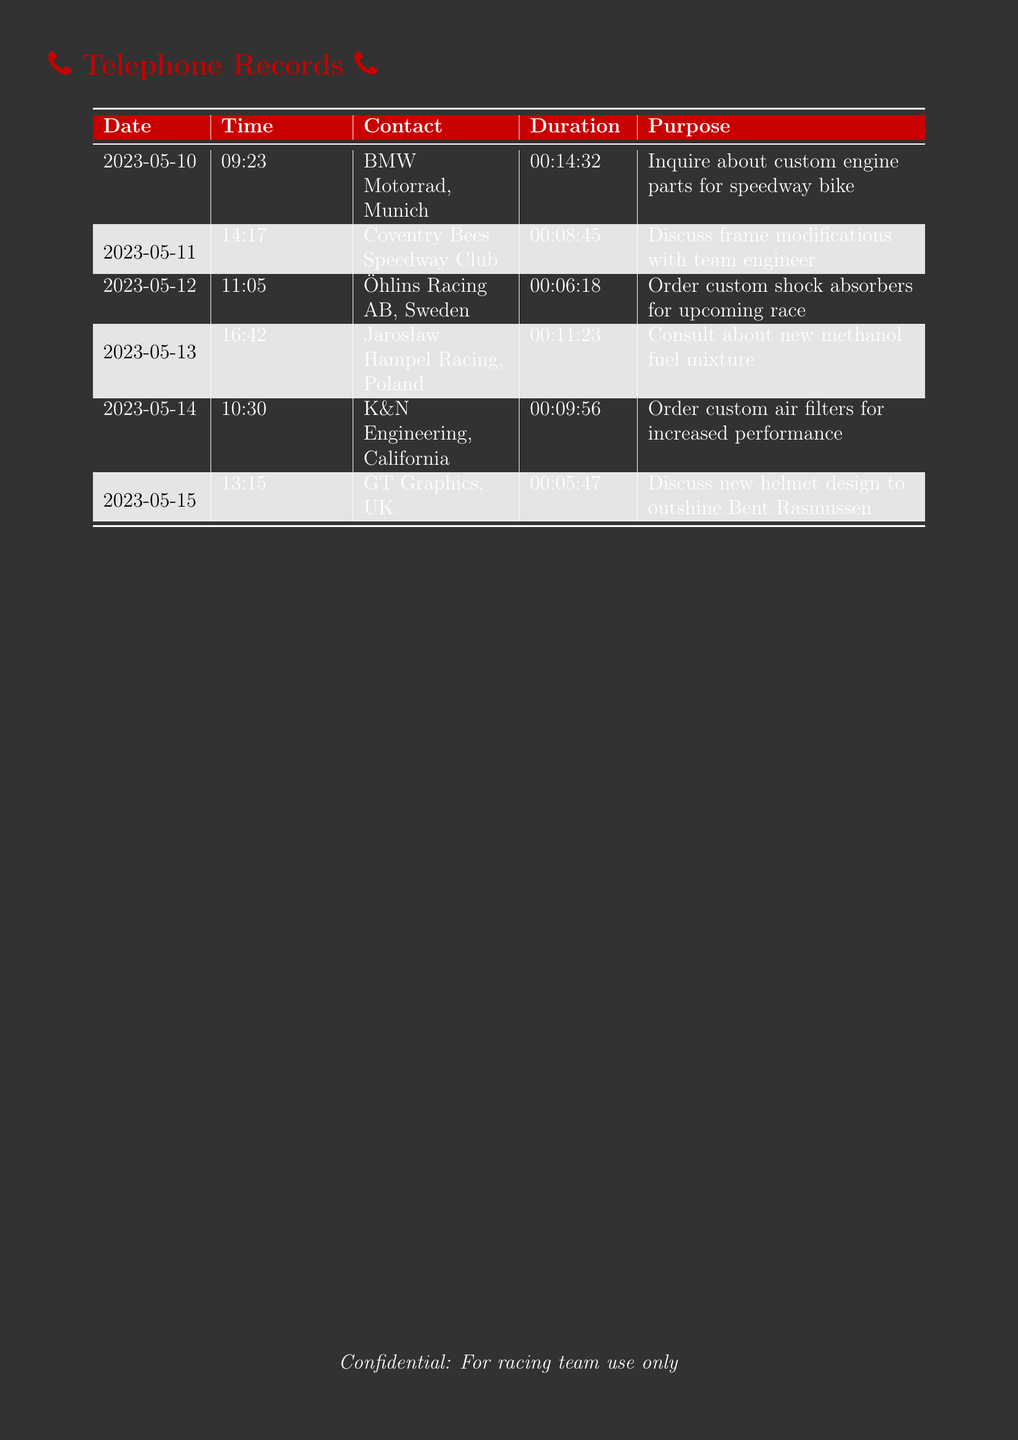What was the purpose of the call on May 10, 2023? The purpose of the call was to inquire about custom engine parts for a speedway bike.
Answer: Inquire about custom engine parts for speedway bike Who did the call on May 12, 2023, involve? The call involved Öhlins Racing AB, Sweden.
Answer: Öhlins Racing AB, Sweden What was the total duration of the calls listed? The total duration can be calculated by adding all call durations: 14:32 + 8:45 + 6:18 + 11:23 + 9:56 + 5:47.
Answer: 56:01 What was discussed in the call with GT Graphics, UK? The discussion was about the new helmet design to outshine Bent Rasmussen.
Answer: Discuss new helmet design to outshine Bent Rasmussen How long was the call to Coventry Bees Speedway Club? The duration of the call was 8 minutes and 45 seconds.
Answer: 00:08:45 What type of racing equipment was ordered from K&N Engineering? Custom air filters were ordered for increased performance.
Answer: Custom air filters for increased performance How many international calls are listed in the document? There are a total of 6 international calls in the document.
Answer: 6 When was the last call made? The last call was made on May 15, 2023.
Answer: May 15, 2023 